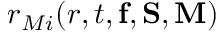Convert formula to latex. <formula><loc_0><loc_0><loc_500><loc_500>r _ { M i } ( r , t , { f } , { S } , { M } )</formula> 